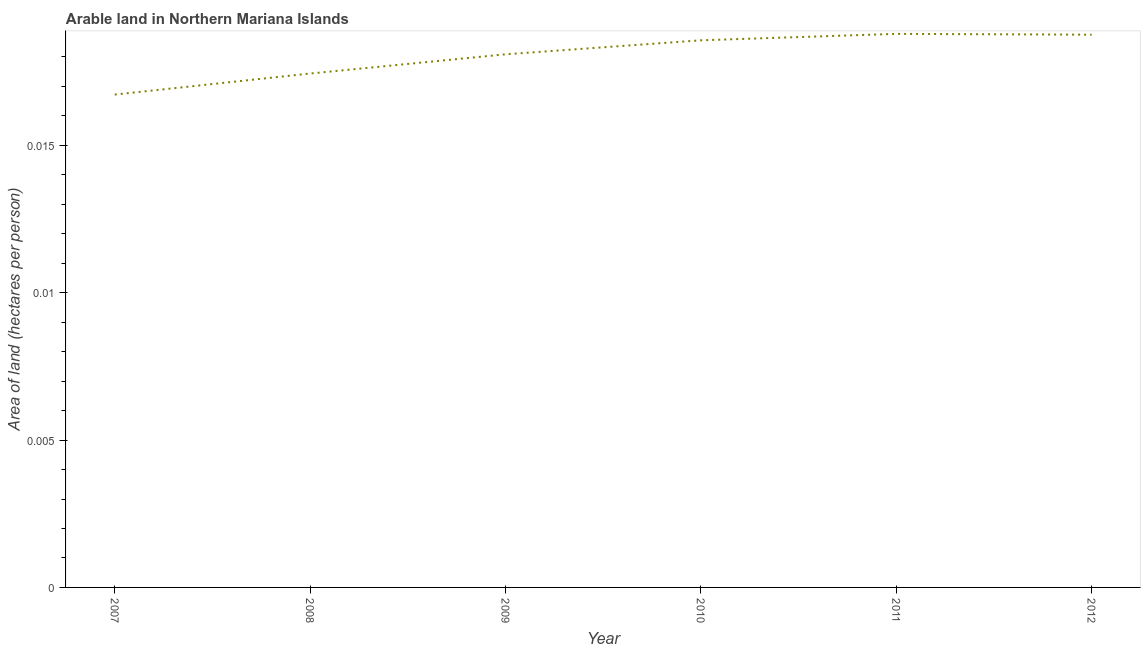What is the area of arable land in 2011?
Your response must be concise. 0.02. Across all years, what is the maximum area of arable land?
Give a very brief answer. 0.02. Across all years, what is the minimum area of arable land?
Give a very brief answer. 0.02. What is the sum of the area of arable land?
Offer a terse response. 0.11. What is the difference between the area of arable land in 2008 and 2009?
Give a very brief answer. -0. What is the average area of arable land per year?
Provide a succinct answer. 0.02. What is the median area of arable land?
Give a very brief answer. 0.02. In how many years, is the area of arable land greater than 0.011 hectares per person?
Your response must be concise. 6. Do a majority of the years between 2007 and 2008 (inclusive) have area of arable land greater than 0.013000000000000001 hectares per person?
Provide a succinct answer. Yes. What is the ratio of the area of arable land in 2009 to that in 2011?
Provide a short and direct response. 0.96. Is the area of arable land in 2010 less than that in 2011?
Your answer should be very brief. Yes. Is the difference between the area of arable land in 2007 and 2009 greater than the difference between any two years?
Ensure brevity in your answer.  No. What is the difference between the highest and the second highest area of arable land?
Your answer should be compact. 2.8187698598199085e-5. Is the sum of the area of arable land in 2008 and 2009 greater than the maximum area of arable land across all years?
Your answer should be compact. Yes. What is the difference between the highest and the lowest area of arable land?
Ensure brevity in your answer.  0. How many lines are there?
Provide a short and direct response. 1. What is the difference between two consecutive major ticks on the Y-axis?
Your answer should be very brief. 0.01. Are the values on the major ticks of Y-axis written in scientific E-notation?
Give a very brief answer. No. Does the graph contain any zero values?
Make the answer very short. No. What is the title of the graph?
Provide a succinct answer. Arable land in Northern Mariana Islands. What is the label or title of the Y-axis?
Give a very brief answer. Area of land (hectares per person). What is the Area of land (hectares per person) of 2007?
Your answer should be very brief. 0.02. What is the Area of land (hectares per person) in 2008?
Provide a short and direct response. 0.02. What is the Area of land (hectares per person) in 2009?
Ensure brevity in your answer.  0.02. What is the Area of land (hectares per person) in 2010?
Ensure brevity in your answer.  0.02. What is the Area of land (hectares per person) in 2011?
Keep it short and to the point. 0.02. What is the Area of land (hectares per person) of 2012?
Make the answer very short. 0.02. What is the difference between the Area of land (hectares per person) in 2007 and 2008?
Your response must be concise. -0. What is the difference between the Area of land (hectares per person) in 2007 and 2009?
Your response must be concise. -0. What is the difference between the Area of land (hectares per person) in 2007 and 2010?
Ensure brevity in your answer.  -0. What is the difference between the Area of land (hectares per person) in 2007 and 2011?
Give a very brief answer. -0. What is the difference between the Area of land (hectares per person) in 2007 and 2012?
Your answer should be very brief. -0. What is the difference between the Area of land (hectares per person) in 2008 and 2009?
Offer a terse response. -0. What is the difference between the Area of land (hectares per person) in 2008 and 2010?
Provide a succinct answer. -0. What is the difference between the Area of land (hectares per person) in 2008 and 2011?
Offer a very short reply. -0. What is the difference between the Area of land (hectares per person) in 2008 and 2012?
Provide a short and direct response. -0. What is the difference between the Area of land (hectares per person) in 2009 and 2010?
Your answer should be very brief. -0. What is the difference between the Area of land (hectares per person) in 2009 and 2011?
Make the answer very short. -0. What is the difference between the Area of land (hectares per person) in 2009 and 2012?
Offer a very short reply. -0. What is the difference between the Area of land (hectares per person) in 2010 and 2011?
Your answer should be compact. -0. What is the difference between the Area of land (hectares per person) in 2010 and 2012?
Provide a succinct answer. -0. What is the difference between the Area of land (hectares per person) in 2011 and 2012?
Your answer should be compact. 3e-5. What is the ratio of the Area of land (hectares per person) in 2007 to that in 2009?
Offer a very short reply. 0.92. What is the ratio of the Area of land (hectares per person) in 2007 to that in 2010?
Provide a succinct answer. 0.9. What is the ratio of the Area of land (hectares per person) in 2007 to that in 2011?
Your response must be concise. 0.89. What is the ratio of the Area of land (hectares per person) in 2007 to that in 2012?
Give a very brief answer. 0.89. What is the ratio of the Area of land (hectares per person) in 2008 to that in 2009?
Provide a short and direct response. 0.96. What is the ratio of the Area of land (hectares per person) in 2008 to that in 2010?
Offer a very short reply. 0.94. What is the ratio of the Area of land (hectares per person) in 2008 to that in 2011?
Provide a short and direct response. 0.93. What is the ratio of the Area of land (hectares per person) in 2010 to that in 2011?
Your answer should be compact. 0.99. What is the ratio of the Area of land (hectares per person) in 2010 to that in 2012?
Provide a short and direct response. 0.99. 